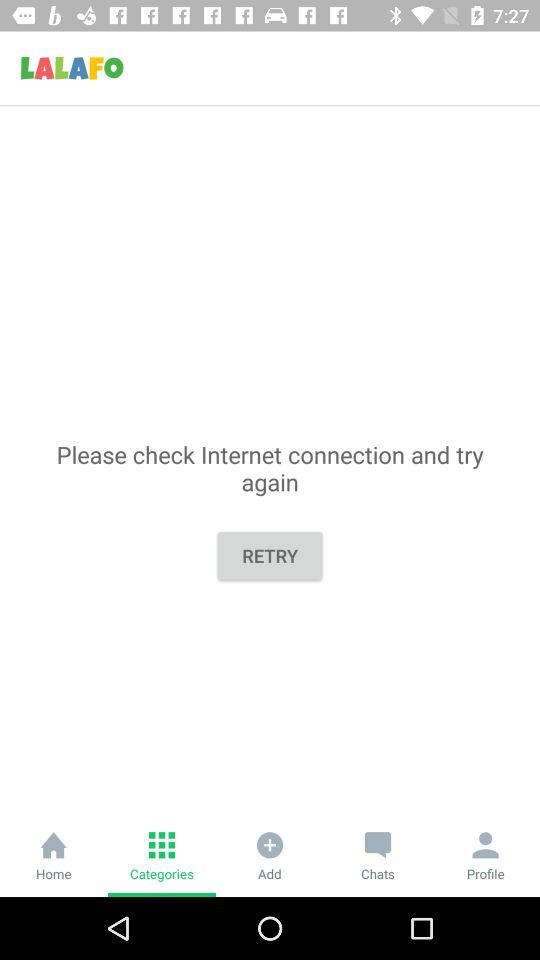Which tab is selected? The selected tab is "Categories". 